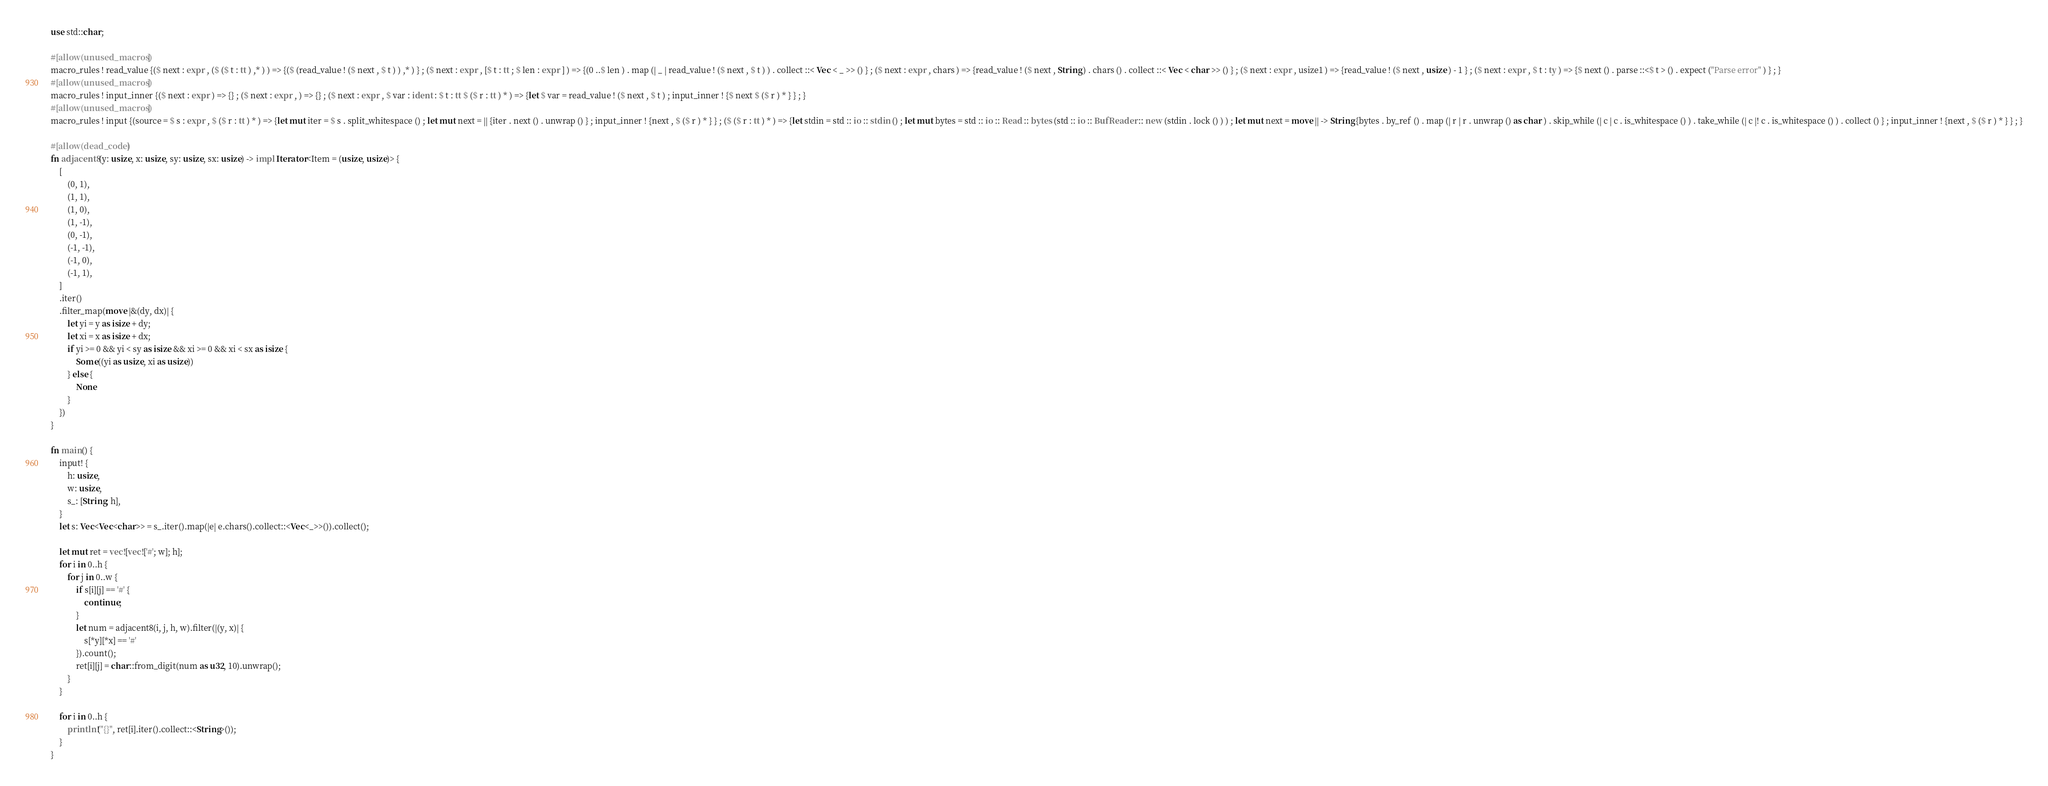<code> <loc_0><loc_0><loc_500><loc_500><_Rust_>use std::char;

#[allow(unused_macros)]
macro_rules ! read_value {($ next : expr , ($ ($ t : tt ) ,* ) ) => {($ (read_value ! ($ next , $ t ) ) ,* ) } ; ($ next : expr , [$ t : tt ; $ len : expr ] ) => {(0 ..$ len ) . map (| _ | read_value ! ($ next , $ t ) ) . collect ::< Vec < _ >> () } ; ($ next : expr , chars ) => {read_value ! ($ next , String ) . chars () . collect ::< Vec < char >> () } ; ($ next : expr , usize1 ) => {read_value ! ($ next , usize ) - 1 } ; ($ next : expr , $ t : ty ) => {$ next () . parse ::<$ t > () . expect ("Parse error" ) } ; }
#[allow(unused_macros)]
macro_rules ! input_inner {($ next : expr ) => {} ; ($ next : expr , ) => {} ; ($ next : expr , $ var : ident : $ t : tt $ ($ r : tt ) * ) => {let $ var = read_value ! ($ next , $ t ) ; input_inner ! {$ next $ ($ r ) * } } ; }
#[allow(unused_macros)]
macro_rules ! input {(source = $ s : expr , $ ($ r : tt ) * ) => {let mut iter = $ s . split_whitespace () ; let mut next = || {iter . next () . unwrap () } ; input_inner ! {next , $ ($ r ) * } } ; ($ ($ r : tt ) * ) => {let stdin = std :: io :: stdin () ; let mut bytes = std :: io :: Read :: bytes (std :: io :: BufReader :: new (stdin . lock () ) ) ; let mut next = move || -> String {bytes . by_ref () . map (| r | r . unwrap () as char ) . skip_while (| c | c . is_whitespace () ) . take_while (| c |! c . is_whitespace () ) . collect () } ; input_inner ! {next , $ ($ r ) * } } ; }

#[allow(dead_code)]
fn adjacent8(y: usize, x: usize, sy: usize, sx: usize) -> impl Iterator<Item = (usize, usize)> {
    [
        (0, 1),
        (1, 1),
        (1, 0),
        (1, -1),
        (0, -1),
        (-1, -1),
        (-1, 0),
        (-1, 1),
    ]
    .iter()
    .filter_map(move |&(dy, dx)| {
        let yi = y as isize + dy;
        let xi = x as isize + dx;
        if yi >= 0 && yi < sy as isize && xi >= 0 && xi < sx as isize {
            Some((yi as usize, xi as usize))
        } else {
            None
        }
    })
}

fn main() {
    input! {
        h: usize,
        w: usize,
        s_: [String; h],
    }
    let s: Vec<Vec<char>> = s_.iter().map(|e| e.chars().collect::<Vec<_>>()).collect();

    let mut ret = vec![vec!['#'; w]; h];
    for i in 0..h {
        for j in 0..w {
            if s[i][j] == '#' {
                continue;
            }
            let num = adjacent8(i, j, h, w).filter(|(y, x)| {
                s[*y][*x] == '#'
            }).count();
            ret[i][j] = char::from_digit(num as u32, 10).unwrap();
        }
    }

    for i in 0..h {
        println!("{}", ret[i].iter().collect::<String>());
    }
}
</code> 